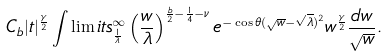Convert formula to latex. <formula><loc_0><loc_0><loc_500><loc_500>C _ { b } | t | ^ { \frac { \gamma } { 2 } } \int \lim i t s _ { \frac { 1 } { \lambda } } ^ { \infty } \left ( \frac { w } { \lambda } \right ) ^ { \frac { b } { 2 } - \frac { 1 } { 4 } - \nu } e ^ { - \cos \theta ( \sqrt { w } - \sqrt { \lambda } ) ^ { 2 } } w ^ { \frac { \gamma } { 2 } } \frac { d w } { \sqrt { w } } .</formula> 